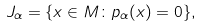<formula> <loc_0><loc_0><loc_500><loc_500>J _ { \alpha } = \{ x \in M \colon p _ { \alpha } ( x ) = 0 \} ,</formula> 